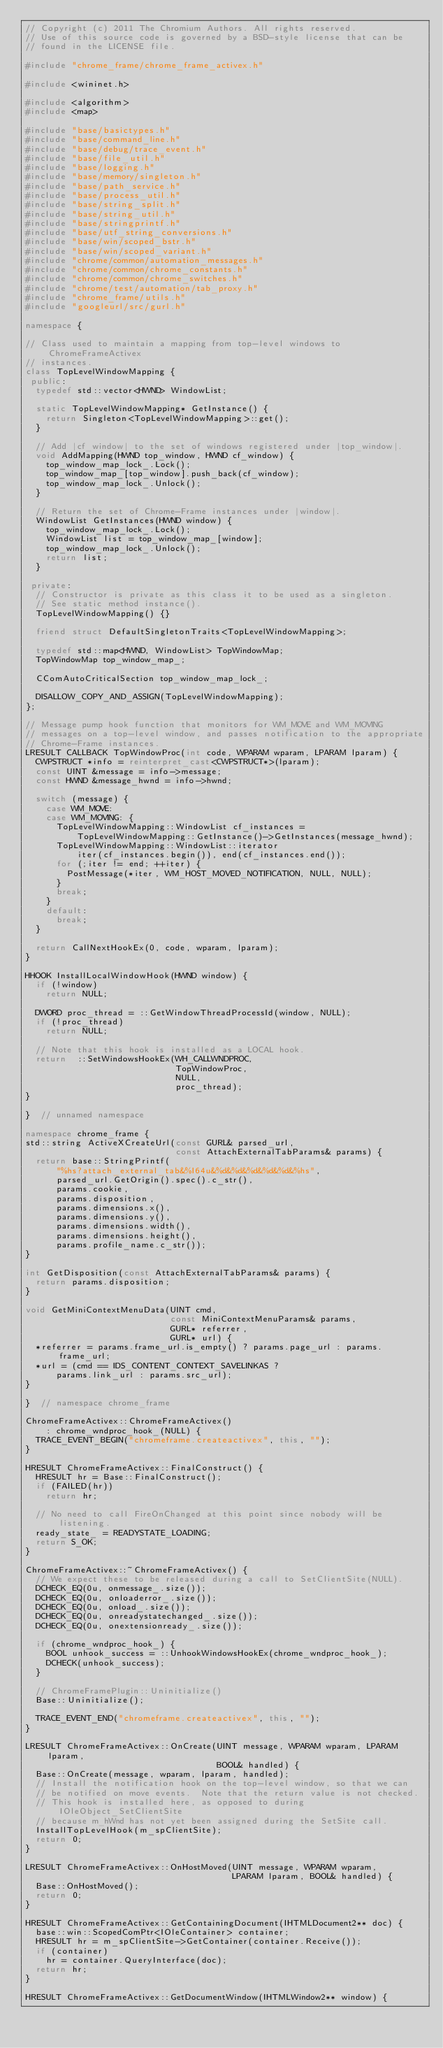Convert code to text. <code><loc_0><loc_0><loc_500><loc_500><_C++_>// Copyright (c) 2011 The Chromium Authors. All rights reserved.
// Use of this source code is governed by a BSD-style license that can be
// found in the LICENSE file.

#include "chrome_frame/chrome_frame_activex.h"

#include <wininet.h>

#include <algorithm>
#include <map>

#include "base/basictypes.h"
#include "base/command_line.h"
#include "base/debug/trace_event.h"
#include "base/file_util.h"
#include "base/logging.h"
#include "base/memory/singleton.h"
#include "base/path_service.h"
#include "base/process_util.h"
#include "base/string_split.h"
#include "base/string_util.h"
#include "base/stringprintf.h"
#include "base/utf_string_conversions.h"
#include "base/win/scoped_bstr.h"
#include "base/win/scoped_variant.h"
#include "chrome/common/automation_messages.h"
#include "chrome/common/chrome_constants.h"
#include "chrome/common/chrome_switches.h"
#include "chrome/test/automation/tab_proxy.h"
#include "chrome_frame/utils.h"
#include "googleurl/src/gurl.h"

namespace {

// Class used to maintain a mapping from top-level windows to ChromeFrameActivex
// instances.
class TopLevelWindowMapping {
 public:
  typedef std::vector<HWND> WindowList;

  static TopLevelWindowMapping* GetInstance() {
    return Singleton<TopLevelWindowMapping>::get();
  }

  // Add |cf_window| to the set of windows registered under |top_window|.
  void AddMapping(HWND top_window, HWND cf_window) {
    top_window_map_lock_.Lock();
    top_window_map_[top_window].push_back(cf_window);
    top_window_map_lock_.Unlock();
  }

  // Return the set of Chrome-Frame instances under |window|.
  WindowList GetInstances(HWND window) {
    top_window_map_lock_.Lock();
    WindowList list = top_window_map_[window];
    top_window_map_lock_.Unlock();
    return list;
  }

 private:
  // Constructor is private as this class it to be used as a singleton.
  // See static method instance().
  TopLevelWindowMapping() {}

  friend struct DefaultSingletonTraits<TopLevelWindowMapping>;

  typedef std::map<HWND, WindowList> TopWindowMap;
  TopWindowMap top_window_map_;

  CComAutoCriticalSection top_window_map_lock_;

  DISALLOW_COPY_AND_ASSIGN(TopLevelWindowMapping);
};

// Message pump hook function that monitors for WM_MOVE and WM_MOVING
// messages on a top-level window, and passes notification to the appropriate
// Chrome-Frame instances.
LRESULT CALLBACK TopWindowProc(int code, WPARAM wparam, LPARAM lparam) {
  CWPSTRUCT *info = reinterpret_cast<CWPSTRUCT*>(lparam);
  const UINT &message = info->message;
  const HWND &message_hwnd = info->hwnd;

  switch (message) {
    case WM_MOVE:
    case WM_MOVING: {
      TopLevelWindowMapping::WindowList cf_instances =
          TopLevelWindowMapping::GetInstance()->GetInstances(message_hwnd);
      TopLevelWindowMapping::WindowList::iterator
          iter(cf_instances.begin()), end(cf_instances.end());
      for (;iter != end; ++iter) {
        PostMessage(*iter, WM_HOST_MOVED_NOTIFICATION, NULL, NULL);
      }
      break;
    }
    default:
      break;
  }

  return CallNextHookEx(0, code, wparam, lparam);
}

HHOOK InstallLocalWindowHook(HWND window) {
  if (!window)
    return NULL;

  DWORD proc_thread = ::GetWindowThreadProcessId(window, NULL);
  if (!proc_thread)
    return NULL;

  // Note that this hook is installed as a LOCAL hook.
  return  ::SetWindowsHookEx(WH_CALLWNDPROC,
                             TopWindowProc,
                             NULL,
                             proc_thread);
}

}  // unnamed namespace

namespace chrome_frame {
std::string ActiveXCreateUrl(const GURL& parsed_url,
                             const AttachExternalTabParams& params) {
  return base::StringPrintf(
      "%hs?attach_external_tab&%I64u&%d&%d&%d&%d&%d&%hs",
      parsed_url.GetOrigin().spec().c_str(),
      params.cookie,
      params.disposition,
      params.dimensions.x(),
      params.dimensions.y(),
      params.dimensions.width(),
      params.dimensions.height(),
      params.profile_name.c_str());
}

int GetDisposition(const AttachExternalTabParams& params) {
  return params.disposition;
}

void GetMiniContextMenuData(UINT cmd,
                            const MiniContextMenuParams& params,
                            GURL* referrer,
                            GURL* url) {
  *referrer = params.frame_url.is_empty() ? params.page_url : params.frame_url;
  *url = (cmd == IDS_CONTENT_CONTEXT_SAVELINKAS ?
      params.link_url : params.src_url);
}

}  // namespace chrome_frame

ChromeFrameActivex::ChromeFrameActivex()
    : chrome_wndproc_hook_(NULL) {
  TRACE_EVENT_BEGIN("chromeframe.createactivex", this, "");
}

HRESULT ChromeFrameActivex::FinalConstruct() {
  HRESULT hr = Base::FinalConstruct();
  if (FAILED(hr))
    return hr;

  // No need to call FireOnChanged at this point since nobody will be listening.
  ready_state_ = READYSTATE_LOADING;
  return S_OK;
}

ChromeFrameActivex::~ChromeFrameActivex() {
  // We expect these to be released during a call to SetClientSite(NULL).
  DCHECK_EQ(0u, onmessage_.size());
  DCHECK_EQ(0u, onloaderror_.size());
  DCHECK_EQ(0u, onload_.size());
  DCHECK_EQ(0u, onreadystatechanged_.size());
  DCHECK_EQ(0u, onextensionready_.size());

  if (chrome_wndproc_hook_) {
    BOOL unhook_success = ::UnhookWindowsHookEx(chrome_wndproc_hook_);
    DCHECK(unhook_success);
  }

  // ChromeFramePlugin::Uninitialize()
  Base::Uninitialize();

  TRACE_EVENT_END("chromeframe.createactivex", this, "");
}

LRESULT ChromeFrameActivex::OnCreate(UINT message, WPARAM wparam, LPARAM lparam,
                                     BOOL& handled) {
  Base::OnCreate(message, wparam, lparam, handled);
  // Install the notification hook on the top-level window, so that we can
  // be notified on move events.  Note that the return value is not checked.
  // This hook is installed here, as opposed to during IOleObject_SetClientSite
  // because m_hWnd has not yet been assigned during the SetSite call.
  InstallTopLevelHook(m_spClientSite);
  return 0;
}

LRESULT ChromeFrameActivex::OnHostMoved(UINT message, WPARAM wparam,
                                        LPARAM lparam, BOOL& handled) {
  Base::OnHostMoved();
  return 0;
}

HRESULT ChromeFrameActivex::GetContainingDocument(IHTMLDocument2** doc) {
  base::win::ScopedComPtr<IOleContainer> container;
  HRESULT hr = m_spClientSite->GetContainer(container.Receive());
  if (container)
    hr = container.QueryInterface(doc);
  return hr;
}

HRESULT ChromeFrameActivex::GetDocumentWindow(IHTMLWindow2** window) {</code> 